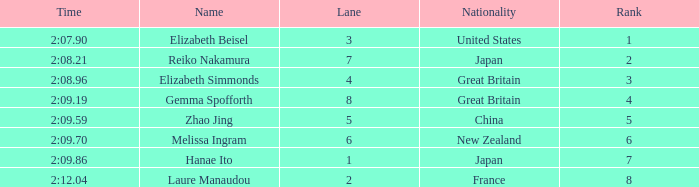What is Elizabeth Simmonds' average lane number? 4.0. 